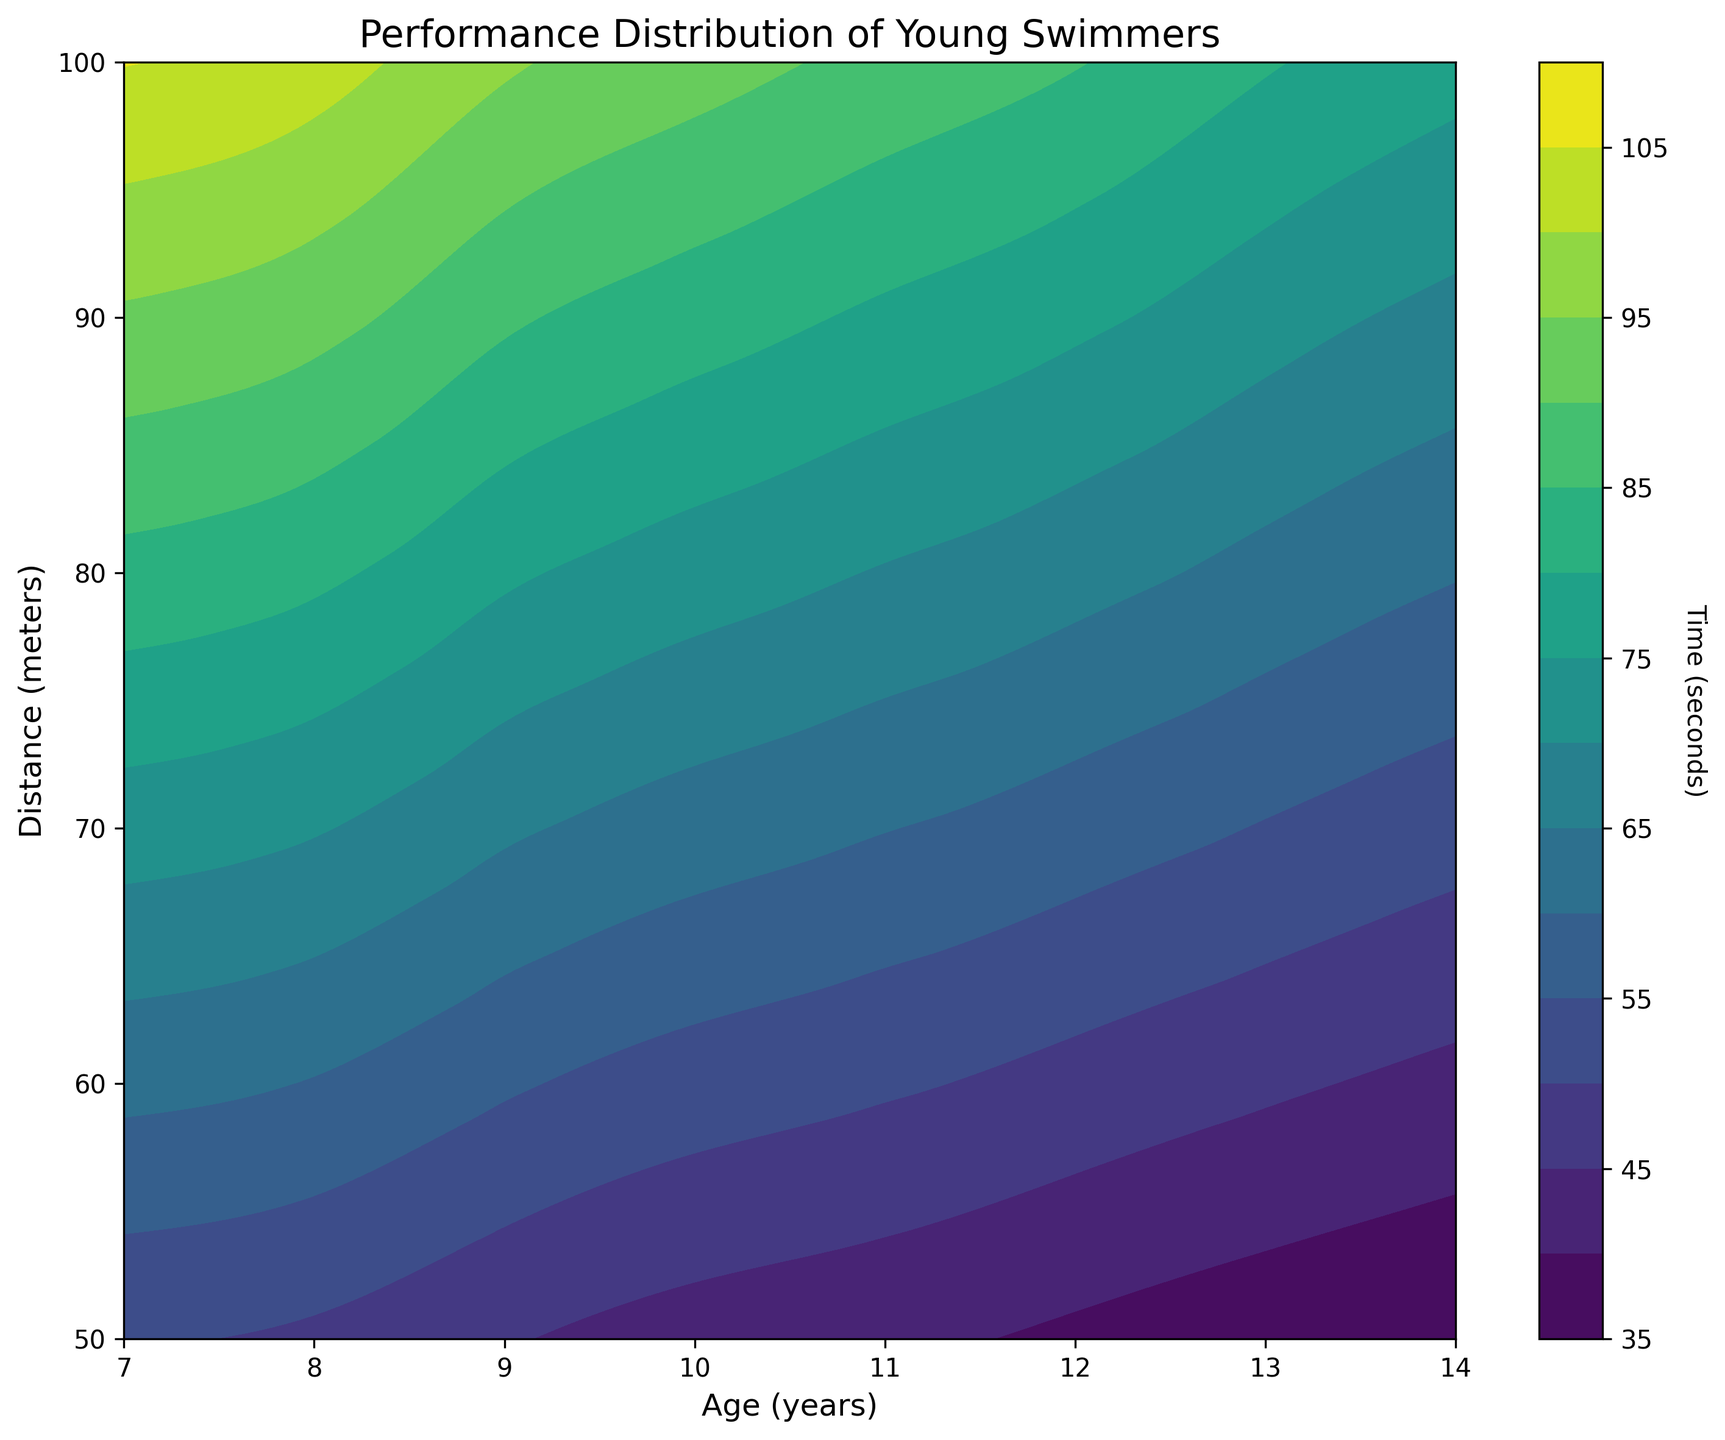What age group has the fastest average time for the 50 meters distance? To determine the fastest average time, look for the lowest time values on the contour plot for the 50 meters distance across different ages. The areas with deeper colors (indicative of lesser times) will represent faster times. The age group with the darkest contour for 50 meters is 14.
Answer: 14 At what approximate age does the performance time for 100 meters start significantly decreasing? To find the starting point of significant decrease in performance time for 100 meters, observe where the contour lines begin to move towards darker colors for the 100 meters distance. This transition seems to occur around age 11.
Answer: 11 Compare the performance improvement between ages 7 and 8 for the 50 meters distance. Which age shows better times and how significant is the improvement? To compare, examine the contour lines for ages 7 and 8 at the 50 meters distance. The colors are darker for age 8, showing improvement. The time improvement is around 50 seconds at age 7 to about 48-47.5 seconds at age 8.
Answer: Age 8, improvement of 2-3 seconds What does the contour color indicate in the plot, and how can you tell which performance times are the best? The contour color signifies the performance time, with darker shades indicating faster times. You can distinguish the best performance times by looking for the darkest areas on the plot, which represent the shortest times.
Answer: Darker colors indicate better times How does the performance of young swimmers change as the distance increases from 50 meters to 100 meters? To find this, examine the difference in contour colors between the distances. For the same age group, the 100 meters distance typically shows lighter colors (longer times) compared to the 50 meters distance, indicating that performance times increase with longer distances.
Answer: Times increase At what age does the performance improvement pattern become most apparent based on the colors for the 50 meters distance? The rapid improvement becomes most visible by examining where there is a noticeable shift in contour colors at the 50 meters distance. This major change begins to show around age 11, where the colors significantly darken.
Answer: Around age 11 Does the trend of improvement in performance times for the 100 meters distance follow a similar pattern to that of the 50 meters? To determine this, compare the pattern of contour color changes for both 50 and 100 meters across ages. Both distances exhibit a similar trend of improvement with age, each showing darker colors as age increases.
Answer: Yes How much faster are 14-year-olds compared to 7-year-olds on average for the 100 meters distance according to the contour plot? To compare, find the difference in the contour levels for 100 meters between ages 14 and 7. The times at age 14 are around 76-77 seconds, while at age 7 it's around 105-108 seconds. The improvement is approximately 30 seconds.
Answer: About 30 seconds Which distance, 50 meters or 100 meters, shows more variability in performance time among the same age group? To assess variability, observe the spread and pattern of contour shading within the same age group for both distances. The 100 meters distance shows a greater range of shading levels for the same age group, indicating more variability in performance times.
Answer: 100 meters 